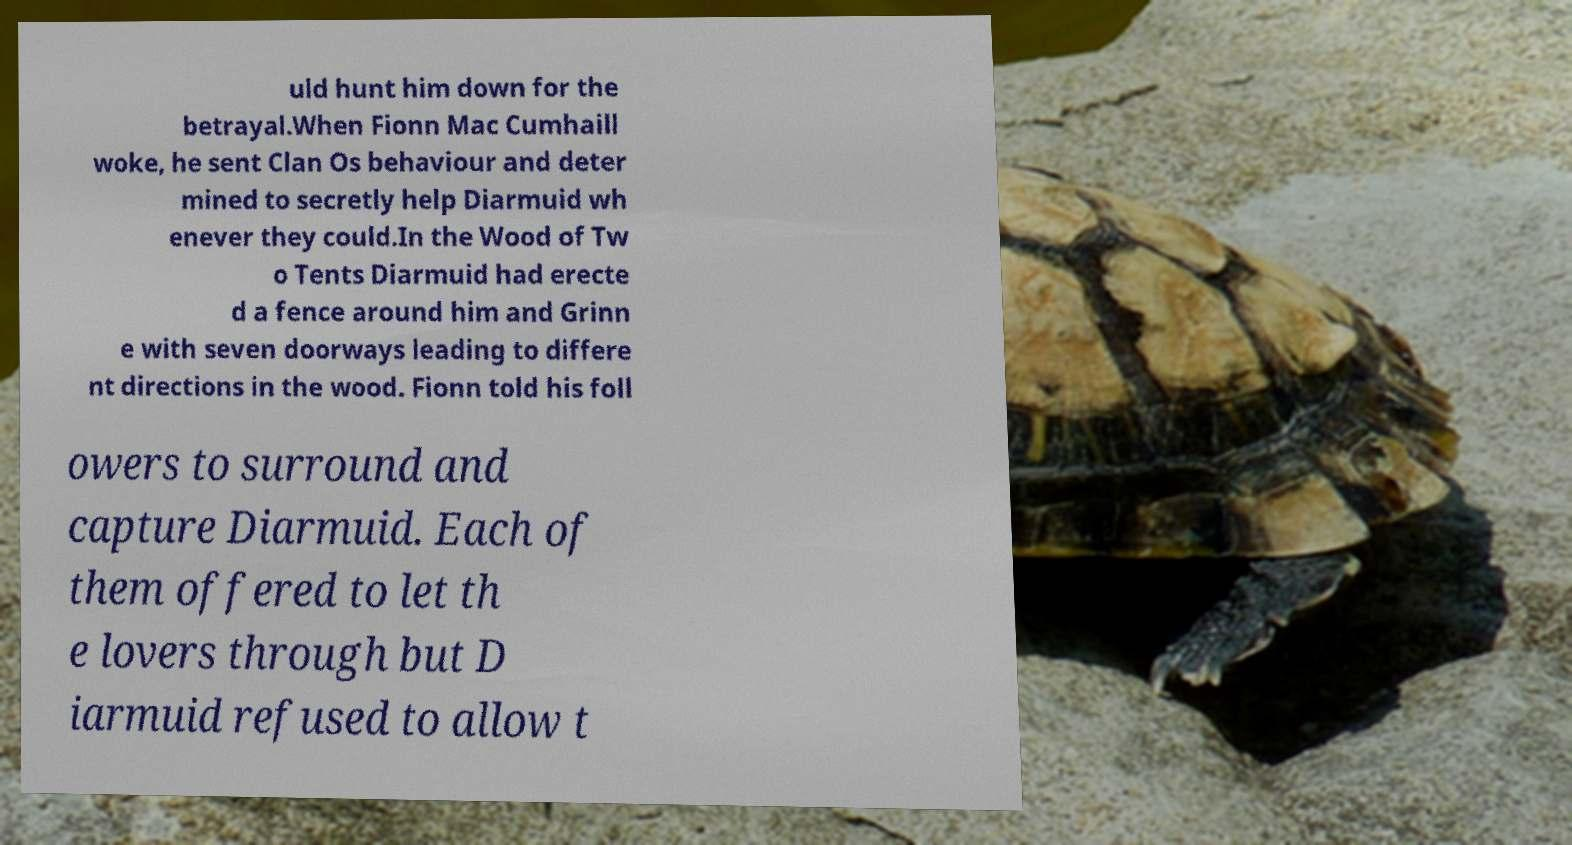For documentation purposes, I need the text within this image transcribed. Could you provide that? uld hunt him down for the betrayal.When Fionn Mac Cumhaill woke, he sent Clan Os behaviour and deter mined to secretly help Diarmuid wh enever they could.In the Wood of Tw o Tents Diarmuid had erecte d a fence around him and Grinn e with seven doorways leading to differe nt directions in the wood. Fionn told his foll owers to surround and capture Diarmuid. Each of them offered to let th e lovers through but D iarmuid refused to allow t 